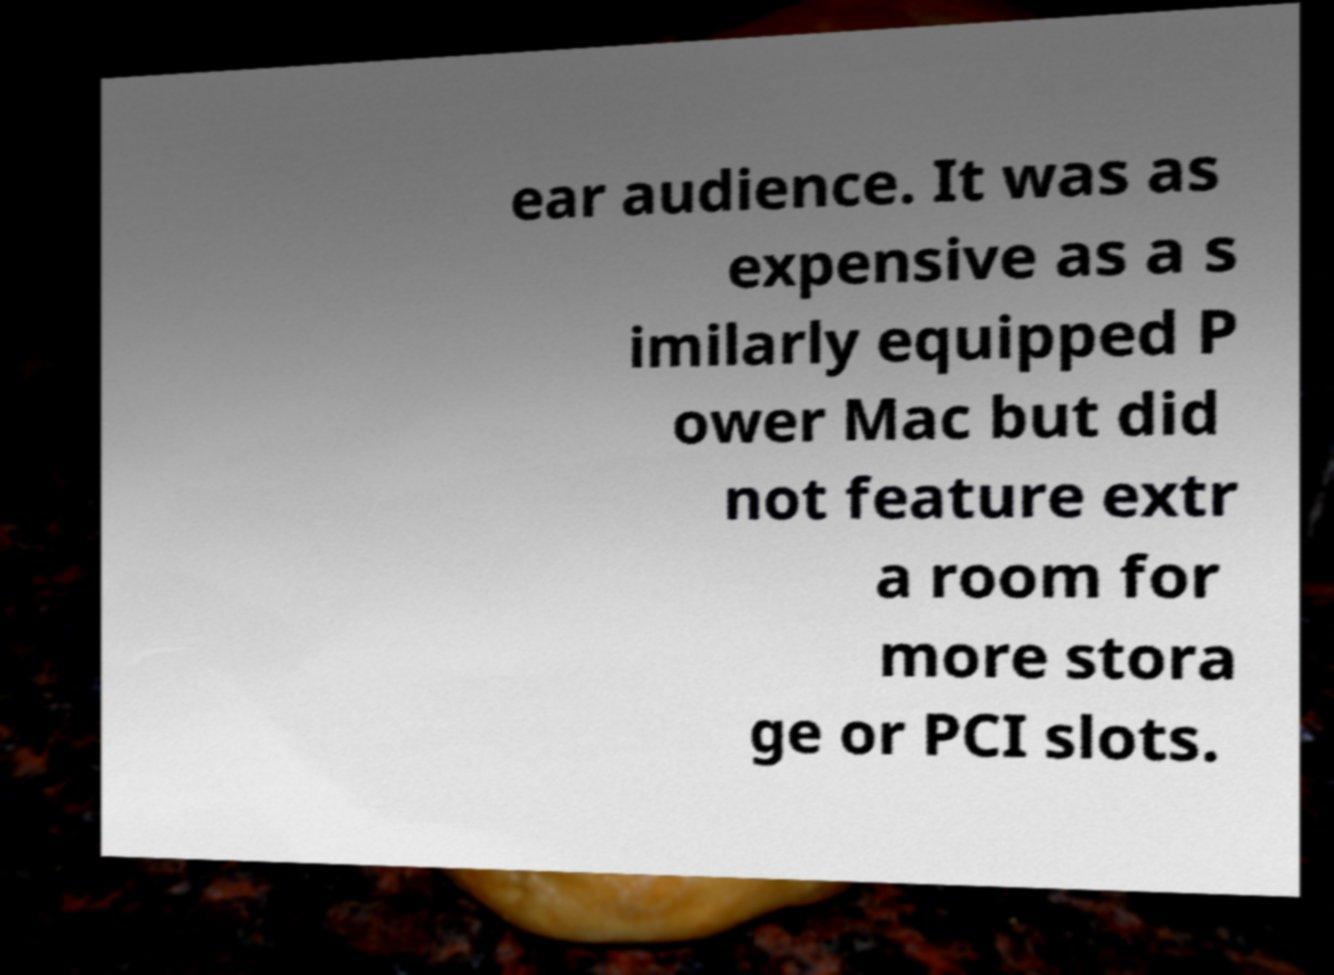Could you assist in decoding the text presented in this image and type it out clearly? ear audience. It was as expensive as a s imilarly equipped P ower Mac but did not feature extr a room for more stora ge or PCI slots. 